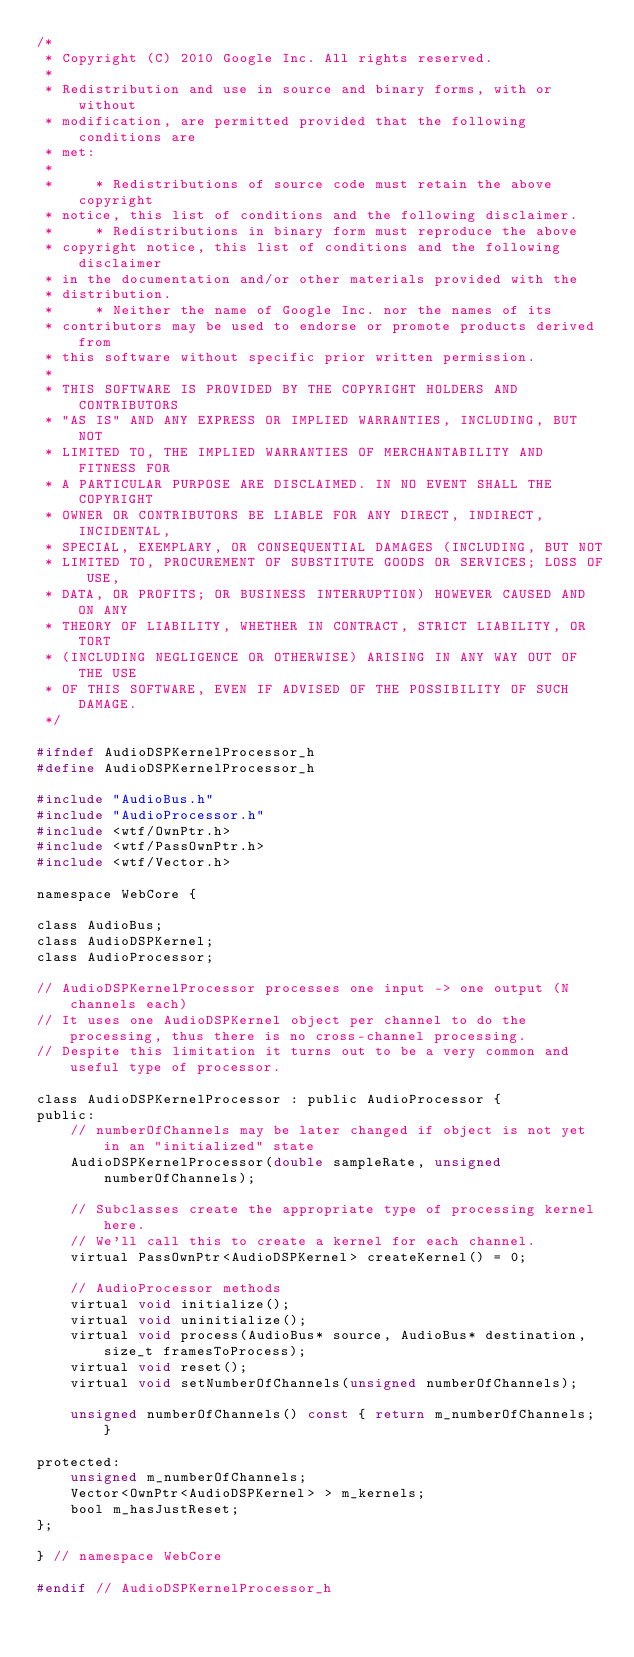<code> <loc_0><loc_0><loc_500><loc_500><_C_>/*
 * Copyright (C) 2010 Google Inc. All rights reserved.
 *
 * Redistribution and use in source and binary forms, with or without
 * modification, are permitted provided that the following conditions are
 * met:
 *
 *     * Redistributions of source code must retain the above copyright
 * notice, this list of conditions and the following disclaimer.
 *     * Redistributions in binary form must reproduce the above
 * copyright notice, this list of conditions and the following disclaimer
 * in the documentation and/or other materials provided with the
 * distribution.
 *     * Neither the name of Google Inc. nor the names of its
 * contributors may be used to endorse or promote products derived from
 * this software without specific prior written permission.
 *
 * THIS SOFTWARE IS PROVIDED BY THE COPYRIGHT HOLDERS AND CONTRIBUTORS
 * "AS IS" AND ANY EXPRESS OR IMPLIED WARRANTIES, INCLUDING, BUT NOT
 * LIMITED TO, THE IMPLIED WARRANTIES OF MERCHANTABILITY AND FITNESS FOR
 * A PARTICULAR PURPOSE ARE DISCLAIMED. IN NO EVENT SHALL THE COPYRIGHT
 * OWNER OR CONTRIBUTORS BE LIABLE FOR ANY DIRECT, INDIRECT, INCIDENTAL,
 * SPECIAL, EXEMPLARY, OR CONSEQUENTIAL DAMAGES (INCLUDING, BUT NOT
 * LIMITED TO, PROCUREMENT OF SUBSTITUTE GOODS OR SERVICES; LOSS OF USE,
 * DATA, OR PROFITS; OR BUSINESS INTERRUPTION) HOWEVER CAUSED AND ON ANY
 * THEORY OF LIABILITY, WHETHER IN CONTRACT, STRICT LIABILITY, OR TORT
 * (INCLUDING NEGLIGENCE OR OTHERWISE) ARISING IN ANY WAY OUT OF THE USE
 * OF THIS SOFTWARE, EVEN IF ADVISED OF THE POSSIBILITY OF SUCH DAMAGE.
 */

#ifndef AudioDSPKernelProcessor_h
#define AudioDSPKernelProcessor_h

#include "AudioBus.h"
#include "AudioProcessor.h"
#include <wtf/OwnPtr.h>
#include <wtf/PassOwnPtr.h>
#include <wtf/Vector.h>

namespace WebCore {

class AudioBus;
class AudioDSPKernel;
class AudioProcessor;

// AudioDSPKernelProcessor processes one input -> one output (N channels each)
// It uses one AudioDSPKernel object per channel to do the processing, thus there is no cross-channel processing.
// Despite this limitation it turns out to be a very common and useful type of processor.

class AudioDSPKernelProcessor : public AudioProcessor {
public:
    // numberOfChannels may be later changed if object is not yet in an "initialized" state
    AudioDSPKernelProcessor(double sampleRate, unsigned numberOfChannels);

    // Subclasses create the appropriate type of processing kernel here.
    // We'll call this to create a kernel for each channel.
    virtual PassOwnPtr<AudioDSPKernel> createKernel() = 0;

    // AudioProcessor methods
    virtual void initialize();
    virtual void uninitialize();
    virtual void process(AudioBus* source, AudioBus* destination, size_t framesToProcess);
    virtual void reset();
    virtual void setNumberOfChannels(unsigned numberOfChannels);

    unsigned numberOfChannels() const { return m_numberOfChannels; }

protected:
    unsigned m_numberOfChannels;
    Vector<OwnPtr<AudioDSPKernel> > m_kernels;
    bool m_hasJustReset;
};

} // namespace WebCore

#endif // AudioDSPKernelProcessor_h
</code> 